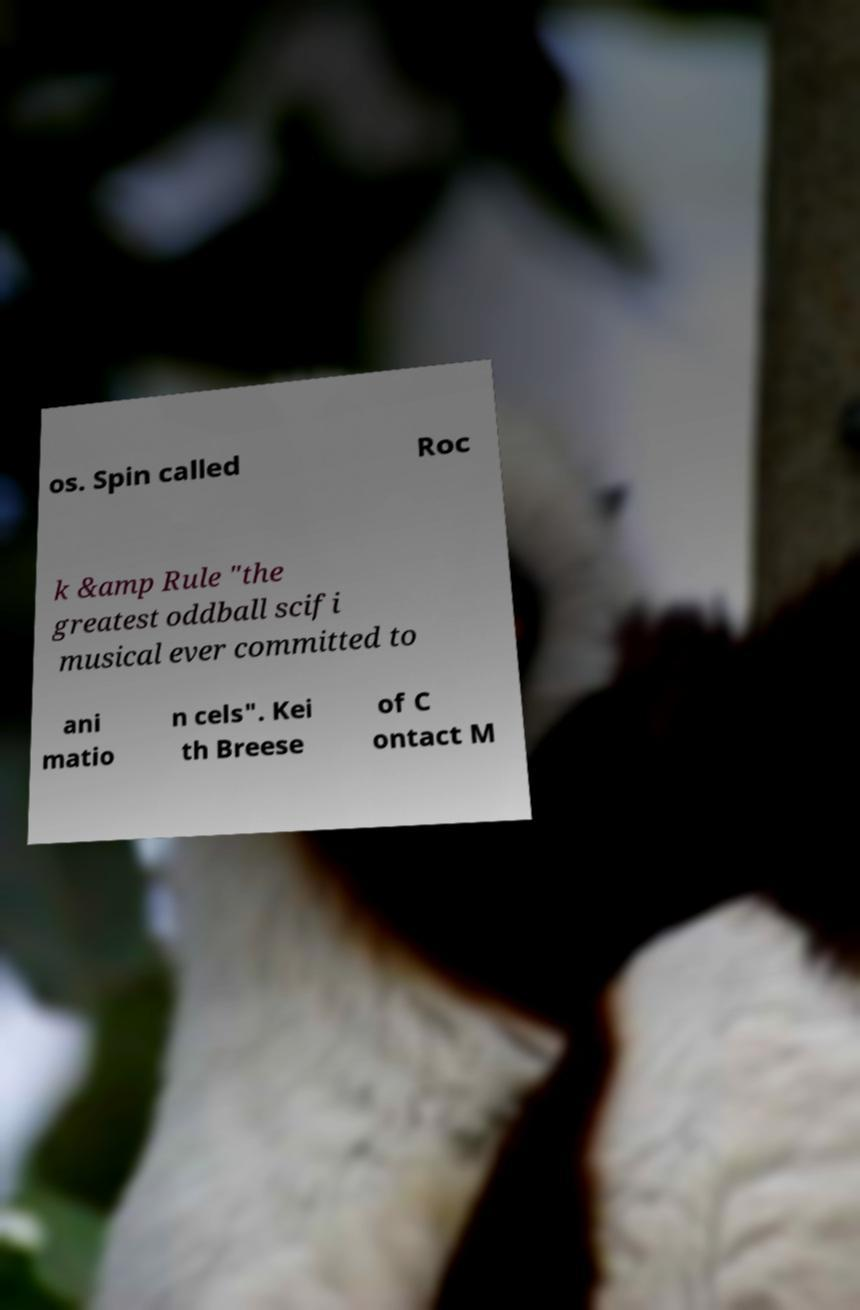Can you read and provide the text displayed in the image?This photo seems to have some interesting text. Can you extract and type it out for me? os. Spin called Roc k &amp Rule "the greatest oddball scifi musical ever committed to ani matio n cels". Kei th Breese of C ontact M 